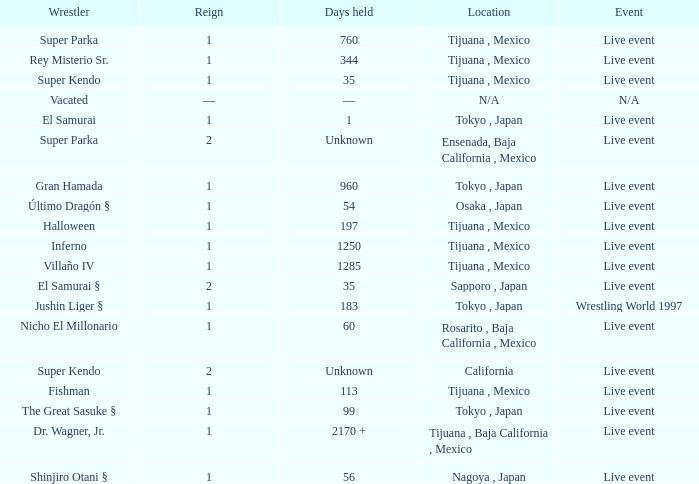What is the reign for super kendo who held it for 35 days? 1.0. 